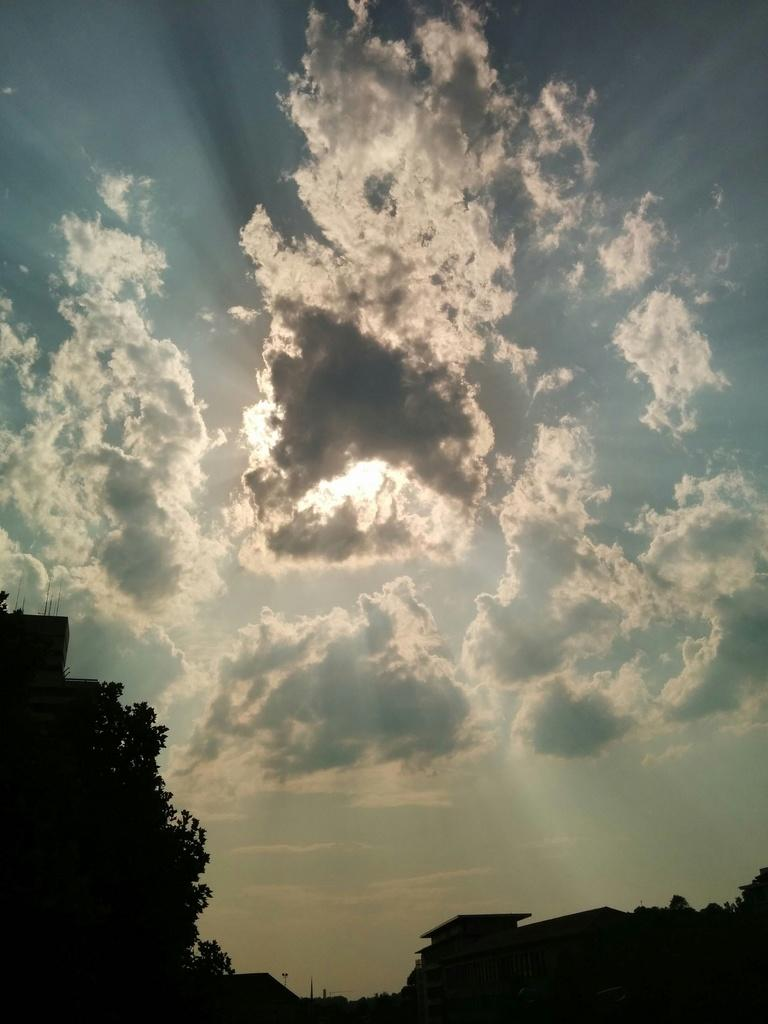What is located at the bottom of the picture? There are trees and buildings at the bottom of the picture. What can be seen in the background of the picture? There are clouds and the sky visible in the background of the picture. Can the sun be seen in the picture? Yes, the sun is observable in the background of the picture. Can you see any monkeys playing in the clouds in the image? There are no monkeys present in the image; it features trees, buildings, clouds, and the sun in the sky. What type of waves can be seen crashing on the shore in the image? There is no shore or waves visible in the image; it primarily shows trees, buildings, clouds, and the sun in the sky. 